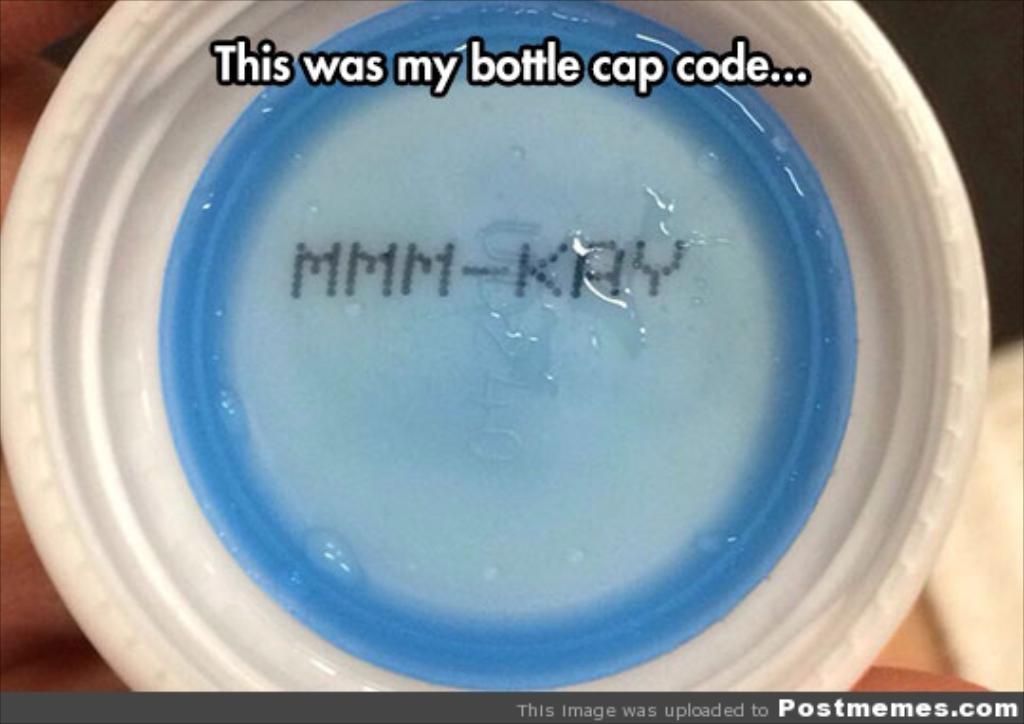Please provide a concise description of this image. This picture contains a bottle cap which is in white and blue color. At the top of the picture, it is written as "This was my bottle cap code...". In the background, it is blurred. 